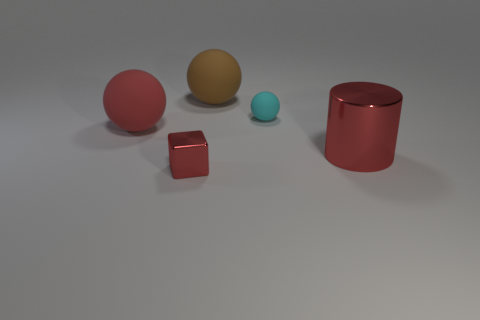Subtract all big spheres. How many spheres are left? 1 Add 3 large red spheres. How many objects exist? 8 Subtract all spheres. How many objects are left? 2 Subtract all tiny matte objects. Subtract all tiny cyan balls. How many objects are left? 3 Add 3 red metallic things. How many red metallic things are left? 5 Add 4 small cyan matte objects. How many small cyan matte objects exist? 5 Subtract 0 blue spheres. How many objects are left? 5 Subtract all blue spheres. Subtract all purple cylinders. How many spheres are left? 3 